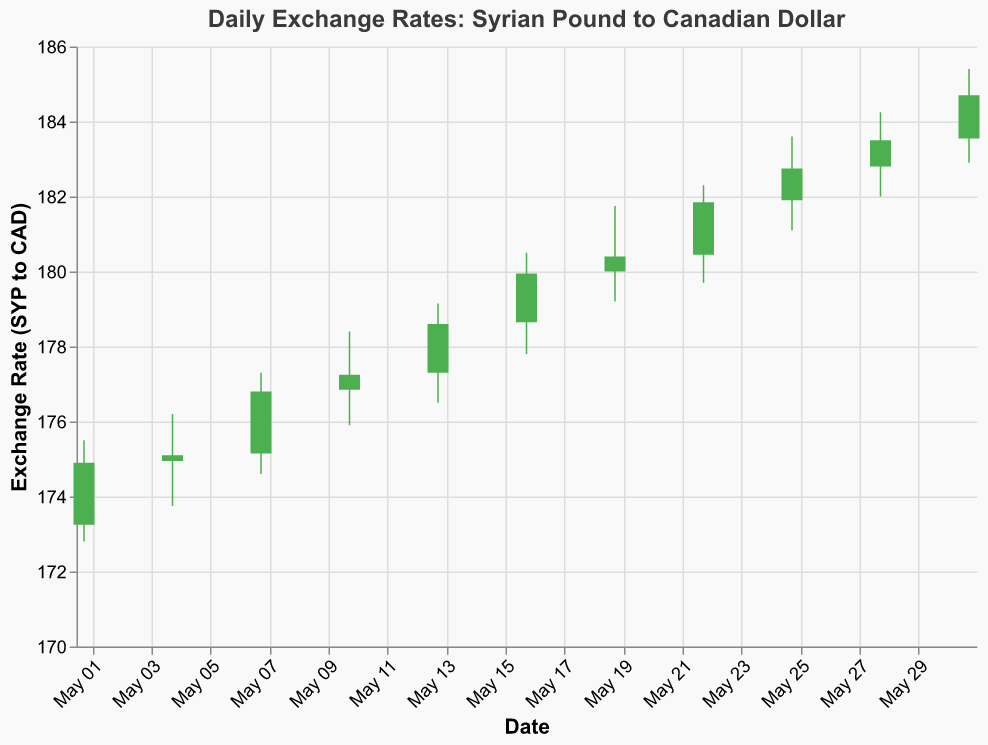What is the title of the chart? The title of the chart is displayed at the top of the figure. It reads, "Daily Exchange Rates: Syrian Pound to Canadian Dollar".
Answer: Daily Exchange Rates: Syrian Pound to Canadian Dollar How many data points are shown in the chart? By counting the number of bars or data points on the x-axis, we can see there are 11 data points, one for each date given in May.
Answer: 11 On which date did the exchange rate have the highest observed value, and what was that value? To find the highest observed value, we look at the highest point in the "High" values of the vertical lines. The highest point is on May 31, at 185.40 SYP to CAD.
Answer: May 31, 185.40 SYP to CAD Which day saw the largest increase in the exchange rate from opening to closing? To determine this, we need to look at the green bars since they indicate an increase from opening to closing. By comparing the heights, we see that May 28 had the largest difference (Close 183.50 - Open 182.80) which is 0.70 SYP.
Answer: May 28, 0.70 SYP What is the average closing exchange rate over the entire month? The closing rates are: 174.90, 175.10, 176.80, 177.25, 178.60, 179.95, 180.40, 181.85, 182.75, 183.50, 184.70. Adding these values gives us a sum of 1995.80. Dividing by the 11 data points gives (1995.80 / 11) ≈ 181.44.
Answer: 181.44 SYP Identify the dates where the exchange rate closed lower than it opened. These dates coincide with the red bars in the chart. The dates are: May 01 (Close 174.90 < Open 173.25) and May 19 (Close 180.40 < Open 180.00).
Answer: May 01, May 19 From May 10 to May 13, how much did the closing exchange rate increase or decrease? On May 10, the closing rate was 177.25 SYP. On May 13, the closing rate was 178.60 SYP. The change is 178.60 - 177.25 = 1.35 SYP, indicating an increase.
Answer: 1.35 SYP increase Comparing the opening rates, on which date did the exchange rate open the highest and what was that rate? Looking at the "Open" values, the highest opening rate is on May 31 with a rate of 183.55 SYP.
Answer: May 31, 183.55 SYP What was the lowest exchange rate recorded in the entire month, and on which day did it occur? The lowest exchange rate is identified by looking at the "Low" values for each day. The lowest rate is 172.80 SYP on May 01.
Answer: 172.80 SYP, May 01 On May 22, did the exchange rate end higher or lower than it opened, and by how much? On May 22, the rate opened at 180.45 SYP and closed at 181.85 SYP. The difference is 181.85 - 180.45 = 1.40 SYP, indicating an increase.
Answer: Higher, 1.40 SYP 